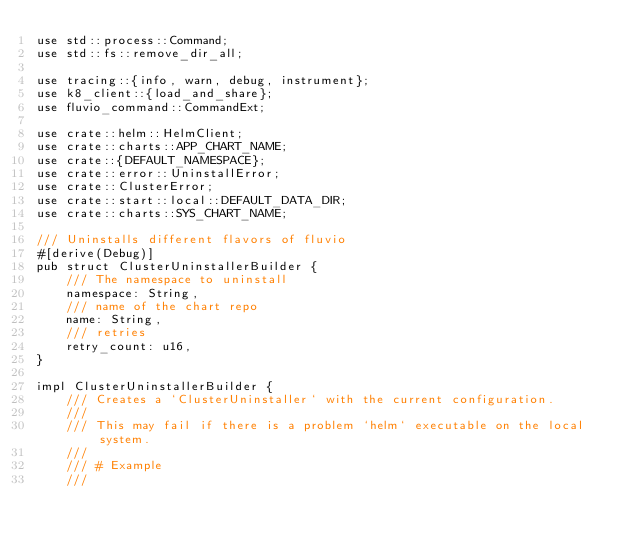Convert code to text. <code><loc_0><loc_0><loc_500><loc_500><_Rust_>use std::process::Command;
use std::fs::remove_dir_all;

use tracing::{info, warn, debug, instrument};
use k8_client::{load_and_share};
use fluvio_command::CommandExt;

use crate::helm::HelmClient;
use crate::charts::APP_CHART_NAME;
use crate::{DEFAULT_NAMESPACE};
use crate::error::UninstallError;
use crate::ClusterError;
use crate::start::local::DEFAULT_DATA_DIR;
use crate::charts::SYS_CHART_NAME;

/// Uninstalls different flavors of fluvio
#[derive(Debug)]
pub struct ClusterUninstallerBuilder {
    /// The namespace to uninstall
    namespace: String,
    /// name of the chart repo
    name: String,
    /// retries
    retry_count: u16,
}

impl ClusterUninstallerBuilder {
    /// Creates a `ClusterUninstaller` with the current configuration.
    ///
    /// This may fail if there is a problem `helm` executable on the local system.
    ///
    /// # Example
    ///</code> 